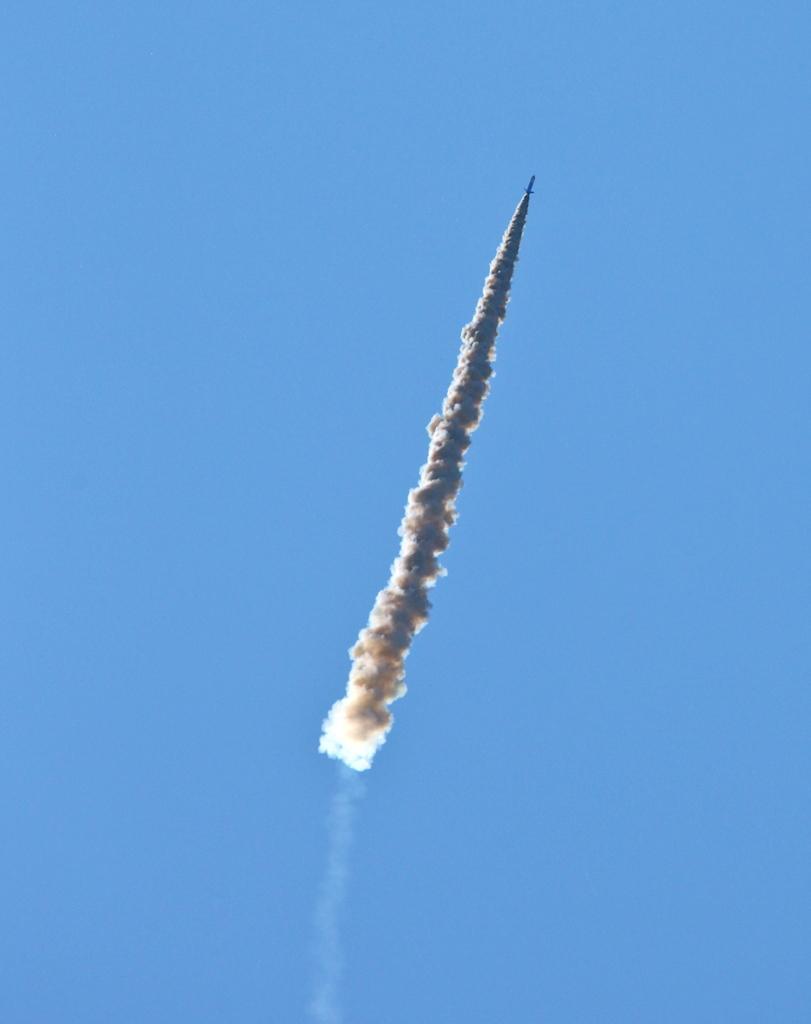Could you give a brief overview of what you see in this image? In this image we can see a rocket in the sky and there is smoke. 